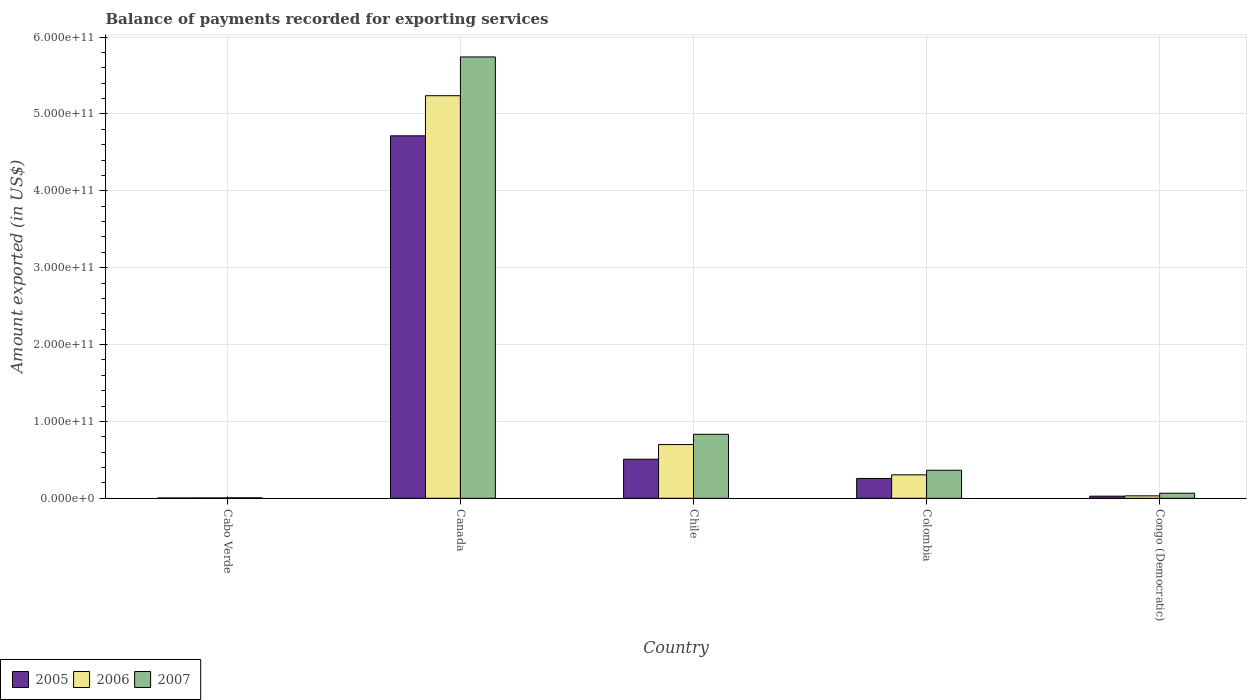How many different coloured bars are there?
Your response must be concise. 3. How many groups of bars are there?
Offer a very short reply. 5. How many bars are there on the 4th tick from the left?
Your answer should be compact. 3. How many bars are there on the 1st tick from the right?
Your answer should be very brief. 3. What is the label of the 5th group of bars from the left?
Offer a very short reply. Congo (Democratic). What is the amount exported in 2006 in Canada?
Your answer should be very brief. 5.24e+11. Across all countries, what is the maximum amount exported in 2007?
Offer a very short reply. 5.74e+11. Across all countries, what is the minimum amount exported in 2005?
Give a very brief answer. 3.73e+08. In which country was the amount exported in 2005 minimum?
Offer a terse response. Cabo Verde. What is the total amount exported in 2007 in the graph?
Your answer should be very brief. 7.01e+11. What is the difference between the amount exported in 2005 in Chile and that in Colombia?
Provide a succinct answer. 2.51e+1. What is the difference between the amount exported in 2005 in Congo (Democratic) and the amount exported in 2007 in Colombia?
Keep it short and to the point. -3.37e+1. What is the average amount exported in 2006 per country?
Your answer should be very brief. 1.26e+11. What is the difference between the amount exported of/in 2005 and amount exported of/in 2007 in Canada?
Your answer should be compact. -1.03e+11. In how many countries, is the amount exported in 2005 greater than 540000000000 US$?
Offer a very short reply. 0. What is the ratio of the amount exported in 2006 in Cabo Verde to that in Congo (Democratic)?
Keep it short and to the point. 0.16. Is the amount exported in 2007 in Cabo Verde less than that in Canada?
Ensure brevity in your answer.  Yes. Is the difference between the amount exported in 2005 in Canada and Colombia greater than the difference between the amount exported in 2007 in Canada and Colombia?
Make the answer very short. No. What is the difference between the highest and the second highest amount exported in 2006?
Offer a terse response. 3.94e+1. What is the difference between the highest and the lowest amount exported in 2007?
Make the answer very short. 5.74e+11. In how many countries, is the amount exported in 2007 greater than the average amount exported in 2007 taken over all countries?
Your answer should be very brief. 1. What does the 2nd bar from the left in Cabo Verde represents?
Provide a short and direct response. 2006. What does the 3rd bar from the right in Chile represents?
Keep it short and to the point. 2005. How many bars are there?
Keep it short and to the point. 15. Are all the bars in the graph horizontal?
Keep it short and to the point. No. What is the difference between two consecutive major ticks on the Y-axis?
Provide a short and direct response. 1.00e+11. Are the values on the major ticks of Y-axis written in scientific E-notation?
Provide a succinct answer. Yes. Does the graph contain grids?
Your response must be concise. Yes. Where does the legend appear in the graph?
Keep it short and to the point. Bottom left. How many legend labels are there?
Your answer should be compact. 3. How are the legend labels stacked?
Provide a succinct answer. Horizontal. What is the title of the graph?
Keep it short and to the point. Balance of payments recorded for exporting services. What is the label or title of the Y-axis?
Ensure brevity in your answer.  Amount exported (in US$). What is the Amount exported (in US$) of 2005 in Cabo Verde?
Provide a succinct answer. 3.73e+08. What is the Amount exported (in US$) in 2006 in Cabo Verde?
Your answer should be compact. 4.91e+08. What is the Amount exported (in US$) of 2007 in Cabo Verde?
Provide a succinct answer. 5.93e+08. What is the Amount exported (in US$) of 2005 in Canada?
Your response must be concise. 4.72e+11. What is the Amount exported (in US$) in 2006 in Canada?
Offer a terse response. 5.24e+11. What is the Amount exported (in US$) of 2007 in Canada?
Give a very brief answer. 5.74e+11. What is the Amount exported (in US$) of 2005 in Chile?
Offer a terse response. 5.09e+1. What is the Amount exported (in US$) of 2006 in Chile?
Make the answer very short. 6.99e+1. What is the Amount exported (in US$) of 2007 in Chile?
Provide a succinct answer. 8.33e+1. What is the Amount exported (in US$) of 2005 in Colombia?
Offer a very short reply. 2.58e+1. What is the Amount exported (in US$) in 2006 in Colombia?
Offer a terse response. 3.05e+1. What is the Amount exported (in US$) of 2007 in Colombia?
Your answer should be very brief. 3.65e+1. What is the Amount exported (in US$) in 2005 in Congo (Democratic)?
Your answer should be compact. 2.76e+09. What is the Amount exported (in US$) of 2006 in Congo (Democratic)?
Your response must be concise. 3.16e+09. What is the Amount exported (in US$) in 2007 in Congo (Democratic)?
Offer a very short reply. 6.57e+09. Across all countries, what is the maximum Amount exported (in US$) in 2005?
Provide a succinct answer. 4.72e+11. Across all countries, what is the maximum Amount exported (in US$) of 2006?
Give a very brief answer. 5.24e+11. Across all countries, what is the maximum Amount exported (in US$) in 2007?
Give a very brief answer. 5.74e+11. Across all countries, what is the minimum Amount exported (in US$) in 2005?
Your response must be concise. 3.73e+08. Across all countries, what is the minimum Amount exported (in US$) in 2006?
Keep it short and to the point. 4.91e+08. Across all countries, what is the minimum Amount exported (in US$) of 2007?
Provide a succinct answer. 5.93e+08. What is the total Amount exported (in US$) of 2005 in the graph?
Your answer should be compact. 5.51e+11. What is the total Amount exported (in US$) in 2006 in the graph?
Ensure brevity in your answer.  6.28e+11. What is the total Amount exported (in US$) in 2007 in the graph?
Offer a terse response. 7.01e+11. What is the difference between the Amount exported (in US$) in 2005 in Cabo Verde and that in Canada?
Give a very brief answer. -4.71e+11. What is the difference between the Amount exported (in US$) of 2006 in Cabo Verde and that in Canada?
Your response must be concise. -5.23e+11. What is the difference between the Amount exported (in US$) in 2007 in Cabo Verde and that in Canada?
Offer a very short reply. -5.74e+11. What is the difference between the Amount exported (in US$) of 2005 in Cabo Verde and that in Chile?
Make the answer very short. -5.05e+1. What is the difference between the Amount exported (in US$) of 2006 in Cabo Verde and that in Chile?
Your answer should be very brief. -6.94e+1. What is the difference between the Amount exported (in US$) in 2007 in Cabo Verde and that in Chile?
Ensure brevity in your answer.  -8.27e+1. What is the difference between the Amount exported (in US$) in 2005 in Cabo Verde and that in Colombia?
Keep it short and to the point. -2.54e+1. What is the difference between the Amount exported (in US$) of 2006 in Cabo Verde and that in Colombia?
Your answer should be compact. -3.00e+1. What is the difference between the Amount exported (in US$) of 2007 in Cabo Verde and that in Colombia?
Your answer should be very brief. -3.59e+1. What is the difference between the Amount exported (in US$) in 2005 in Cabo Verde and that in Congo (Democratic)?
Offer a very short reply. -2.38e+09. What is the difference between the Amount exported (in US$) in 2006 in Cabo Verde and that in Congo (Democratic)?
Your response must be concise. -2.66e+09. What is the difference between the Amount exported (in US$) in 2007 in Cabo Verde and that in Congo (Democratic)?
Give a very brief answer. -5.97e+09. What is the difference between the Amount exported (in US$) in 2005 in Canada and that in Chile?
Offer a very short reply. 4.21e+11. What is the difference between the Amount exported (in US$) in 2006 in Canada and that in Chile?
Provide a succinct answer. 4.54e+11. What is the difference between the Amount exported (in US$) of 2007 in Canada and that in Chile?
Offer a very short reply. 4.91e+11. What is the difference between the Amount exported (in US$) of 2005 in Canada and that in Colombia?
Make the answer very short. 4.46e+11. What is the difference between the Amount exported (in US$) in 2006 in Canada and that in Colombia?
Provide a succinct answer. 4.93e+11. What is the difference between the Amount exported (in US$) in 2007 in Canada and that in Colombia?
Your response must be concise. 5.38e+11. What is the difference between the Amount exported (in US$) of 2005 in Canada and that in Congo (Democratic)?
Give a very brief answer. 4.69e+11. What is the difference between the Amount exported (in US$) in 2006 in Canada and that in Congo (Democratic)?
Offer a very short reply. 5.21e+11. What is the difference between the Amount exported (in US$) of 2007 in Canada and that in Congo (Democratic)?
Make the answer very short. 5.68e+11. What is the difference between the Amount exported (in US$) of 2005 in Chile and that in Colombia?
Your response must be concise. 2.51e+1. What is the difference between the Amount exported (in US$) of 2006 in Chile and that in Colombia?
Ensure brevity in your answer.  3.94e+1. What is the difference between the Amount exported (in US$) of 2007 in Chile and that in Colombia?
Give a very brief answer. 4.68e+1. What is the difference between the Amount exported (in US$) of 2005 in Chile and that in Congo (Democratic)?
Your answer should be very brief. 4.81e+1. What is the difference between the Amount exported (in US$) in 2006 in Chile and that in Congo (Democratic)?
Keep it short and to the point. 6.67e+1. What is the difference between the Amount exported (in US$) in 2007 in Chile and that in Congo (Democratic)?
Your answer should be compact. 7.67e+1. What is the difference between the Amount exported (in US$) in 2005 in Colombia and that in Congo (Democratic)?
Your answer should be very brief. 2.30e+1. What is the difference between the Amount exported (in US$) in 2006 in Colombia and that in Congo (Democratic)?
Offer a very short reply. 2.73e+1. What is the difference between the Amount exported (in US$) in 2007 in Colombia and that in Congo (Democratic)?
Provide a succinct answer. 2.99e+1. What is the difference between the Amount exported (in US$) of 2005 in Cabo Verde and the Amount exported (in US$) of 2006 in Canada?
Provide a short and direct response. -5.23e+11. What is the difference between the Amount exported (in US$) of 2005 in Cabo Verde and the Amount exported (in US$) of 2007 in Canada?
Give a very brief answer. -5.74e+11. What is the difference between the Amount exported (in US$) in 2006 in Cabo Verde and the Amount exported (in US$) in 2007 in Canada?
Give a very brief answer. -5.74e+11. What is the difference between the Amount exported (in US$) of 2005 in Cabo Verde and the Amount exported (in US$) of 2006 in Chile?
Provide a short and direct response. -6.95e+1. What is the difference between the Amount exported (in US$) of 2005 in Cabo Verde and the Amount exported (in US$) of 2007 in Chile?
Offer a terse response. -8.29e+1. What is the difference between the Amount exported (in US$) in 2006 in Cabo Verde and the Amount exported (in US$) in 2007 in Chile?
Give a very brief answer. -8.28e+1. What is the difference between the Amount exported (in US$) in 2005 in Cabo Verde and the Amount exported (in US$) in 2006 in Colombia?
Keep it short and to the point. -3.01e+1. What is the difference between the Amount exported (in US$) of 2005 in Cabo Verde and the Amount exported (in US$) of 2007 in Colombia?
Your response must be concise. -3.61e+1. What is the difference between the Amount exported (in US$) in 2006 in Cabo Verde and the Amount exported (in US$) in 2007 in Colombia?
Provide a succinct answer. -3.60e+1. What is the difference between the Amount exported (in US$) of 2005 in Cabo Verde and the Amount exported (in US$) of 2006 in Congo (Democratic)?
Keep it short and to the point. -2.78e+09. What is the difference between the Amount exported (in US$) of 2005 in Cabo Verde and the Amount exported (in US$) of 2007 in Congo (Democratic)?
Offer a terse response. -6.19e+09. What is the difference between the Amount exported (in US$) in 2006 in Cabo Verde and the Amount exported (in US$) in 2007 in Congo (Democratic)?
Ensure brevity in your answer.  -6.07e+09. What is the difference between the Amount exported (in US$) in 2005 in Canada and the Amount exported (in US$) in 2006 in Chile?
Your response must be concise. 4.02e+11. What is the difference between the Amount exported (in US$) of 2005 in Canada and the Amount exported (in US$) of 2007 in Chile?
Your response must be concise. 3.88e+11. What is the difference between the Amount exported (in US$) in 2006 in Canada and the Amount exported (in US$) in 2007 in Chile?
Ensure brevity in your answer.  4.40e+11. What is the difference between the Amount exported (in US$) in 2005 in Canada and the Amount exported (in US$) in 2006 in Colombia?
Offer a very short reply. 4.41e+11. What is the difference between the Amount exported (in US$) in 2005 in Canada and the Amount exported (in US$) in 2007 in Colombia?
Offer a terse response. 4.35e+11. What is the difference between the Amount exported (in US$) in 2006 in Canada and the Amount exported (in US$) in 2007 in Colombia?
Give a very brief answer. 4.87e+11. What is the difference between the Amount exported (in US$) in 2005 in Canada and the Amount exported (in US$) in 2006 in Congo (Democratic)?
Provide a short and direct response. 4.68e+11. What is the difference between the Amount exported (in US$) in 2005 in Canada and the Amount exported (in US$) in 2007 in Congo (Democratic)?
Give a very brief answer. 4.65e+11. What is the difference between the Amount exported (in US$) in 2006 in Canada and the Amount exported (in US$) in 2007 in Congo (Democratic)?
Provide a short and direct response. 5.17e+11. What is the difference between the Amount exported (in US$) of 2005 in Chile and the Amount exported (in US$) of 2006 in Colombia?
Make the answer very short. 2.04e+1. What is the difference between the Amount exported (in US$) in 2005 in Chile and the Amount exported (in US$) in 2007 in Colombia?
Your answer should be compact. 1.44e+1. What is the difference between the Amount exported (in US$) of 2006 in Chile and the Amount exported (in US$) of 2007 in Colombia?
Ensure brevity in your answer.  3.34e+1. What is the difference between the Amount exported (in US$) of 2005 in Chile and the Amount exported (in US$) of 2006 in Congo (Democratic)?
Your answer should be compact. 4.77e+1. What is the difference between the Amount exported (in US$) in 2005 in Chile and the Amount exported (in US$) in 2007 in Congo (Democratic)?
Keep it short and to the point. 4.43e+1. What is the difference between the Amount exported (in US$) in 2006 in Chile and the Amount exported (in US$) in 2007 in Congo (Democratic)?
Offer a very short reply. 6.33e+1. What is the difference between the Amount exported (in US$) in 2005 in Colombia and the Amount exported (in US$) in 2006 in Congo (Democratic)?
Ensure brevity in your answer.  2.26e+1. What is the difference between the Amount exported (in US$) of 2005 in Colombia and the Amount exported (in US$) of 2007 in Congo (Democratic)?
Keep it short and to the point. 1.92e+1. What is the difference between the Amount exported (in US$) in 2006 in Colombia and the Amount exported (in US$) in 2007 in Congo (Democratic)?
Provide a short and direct response. 2.39e+1. What is the average Amount exported (in US$) of 2005 per country?
Your response must be concise. 1.10e+11. What is the average Amount exported (in US$) in 2006 per country?
Your answer should be very brief. 1.26e+11. What is the average Amount exported (in US$) of 2007 per country?
Provide a short and direct response. 1.40e+11. What is the difference between the Amount exported (in US$) of 2005 and Amount exported (in US$) of 2006 in Cabo Verde?
Provide a short and direct response. -1.18e+08. What is the difference between the Amount exported (in US$) of 2005 and Amount exported (in US$) of 2007 in Cabo Verde?
Offer a terse response. -2.20e+08. What is the difference between the Amount exported (in US$) of 2006 and Amount exported (in US$) of 2007 in Cabo Verde?
Ensure brevity in your answer.  -1.01e+08. What is the difference between the Amount exported (in US$) of 2005 and Amount exported (in US$) of 2006 in Canada?
Give a very brief answer. -5.22e+1. What is the difference between the Amount exported (in US$) of 2005 and Amount exported (in US$) of 2007 in Canada?
Make the answer very short. -1.03e+11. What is the difference between the Amount exported (in US$) in 2006 and Amount exported (in US$) in 2007 in Canada?
Your answer should be very brief. -5.04e+1. What is the difference between the Amount exported (in US$) of 2005 and Amount exported (in US$) of 2006 in Chile?
Give a very brief answer. -1.90e+1. What is the difference between the Amount exported (in US$) of 2005 and Amount exported (in US$) of 2007 in Chile?
Offer a terse response. -3.24e+1. What is the difference between the Amount exported (in US$) in 2006 and Amount exported (in US$) in 2007 in Chile?
Keep it short and to the point. -1.34e+1. What is the difference between the Amount exported (in US$) in 2005 and Amount exported (in US$) in 2006 in Colombia?
Your answer should be compact. -4.70e+09. What is the difference between the Amount exported (in US$) in 2005 and Amount exported (in US$) in 2007 in Colombia?
Make the answer very short. -1.07e+1. What is the difference between the Amount exported (in US$) in 2006 and Amount exported (in US$) in 2007 in Colombia?
Offer a terse response. -5.97e+09. What is the difference between the Amount exported (in US$) of 2005 and Amount exported (in US$) of 2006 in Congo (Democratic)?
Your answer should be compact. -4.00e+08. What is the difference between the Amount exported (in US$) of 2005 and Amount exported (in US$) of 2007 in Congo (Democratic)?
Your answer should be very brief. -3.81e+09. What is the difference between the Amount exported (in US$) in 2006 and Amount exported (in US$) in 2007 in Congo (Democratic)?
Provide a short and direct response. -3.41e+09. What is the ratio of the Amount exported (in US$) in 2005 in Cabo Verde to that in Canada?
Provide a succinct answer. 0. What is the ratio of the Amount exported (in US$) of 2006 in Cabo Verde to that in Canada?
Keep it short and to the point. 0. What is the ratio of the Amount exported (in US$) of 2007 in Cabo Verde to that in Canada?
Offer a very short reply. 0. What is the ratio of the Amount exported (in US$) of 2005 in Cabo Verde to that in Chile?
Make the answer very short. 0.01. What is the ratio of the Amount exported (in US$) of 2006 in Cabo Verde to that in Chile?
Your response must be concise. 0.01. What is the ratio of the Amount exported (in US$) of 2007 in Cabo Verde to that in Chile?
Offer a very short reply. 0.01. What is the ratio of the Amount exported (in US$) in 2005 in Cabo Verde to that in Colombia?
Keep it short and to the point. 0.01. What is the ratio of the Amount exported (in US$) of 2006 in Cabo Verde to that in Colombia?
Keep it short and to the point. 0.02. What is the ratio of the Amount exported (in US$) in 2007 in Cabo Verde to that in Colombia?
Give a very brief answer. 0.02. What is the ratio of the Amount exported (in US$) of 2005 in Cabo Verde to that in Congo (Democratic)?
Your response must be concise. 0.14. What is the ratio of the Amount exported (in US$) in 2006 in Cabo Verde to that in Congo (Democratic)?
Offer a very short reply. 0.16. What is the ratio of the Amount exported (in US$) in 2007 in Cabo Verde to that in Congo (Democratic)?
Your response must be concise. 0.09. What is the ratio of the Amount exported (in US$) in 2005 in Canada to that in Chile?
Your response must be concise. 9.27. What is the ratio of the Amount exported (in US$) in 2006 in Canada to that in Chile?
Keep it short and to the point. 7.49. What is the ratio of the Amount exported (in US$) in 2007 in Canada to that in Chile?
Provide a short and direct response. 6.9. What is the ratio of the Amount exported (in US$) of 2005 in Canada to that in Colombia?
Provide a short and direct response. 18.29. What is the ratio of the Amount exported (in US$) of 2006 in Canada to that in Colombia?
Give a very brief answer. 17.18. What is the ratio of the Amount exported (in US$) of 2007 in Canada to that in Colombia?
Ensure brevity in your answer.  15.75. What is the ratio of the Amount exported (in US$) of 2005 in Canada to that in Congo (Democratic)?
Keep it short and to the point. 171.13. What is the ratio of the Amount exported (in US$) of 2006 in Canada to that in Congo (Democratic)?
Offer a very short reply. 165.99. What is the ratio of the Amount exported (in US$) of 2007 in Canada to that in Congo (Democratic)?
Give a very brief answer. 87.44. What is the ratio of the Amount exported (in US$) in 2005 in Chile to that in Colombia?
Ensure brevity in your answer.  1.97. What is the ratio of the Amount exported (in US$) in 2006 in Chile to that in Colombia?
Provide a succinct answer. 2.29. What is the ratio of the Amount exported (in US$) in 2007 in Chile to that in Colombia?
Give a very brief answer. 2.28. What is the ratio of the Amount exported (in US$) in 2005 in Chile to that in Congo (Democratic)?
Keep it short and to the point. 18.46. What is the ratio of the Amount exported (in US$) in 2006 in Chile to that in Congo (Democratic)?
Ensure brevity in your answer.  22.15. What is the ratio of the Amount exported (in US$) of 2007 in Chile to that in Congo (Democratic)?
Provide a short and direct response. 12.68. What is the ratio of the Amount exported (in US$) of 2005 in Colombia to that in Congo (Democratic)?
Offer a terse response. 9.36. What is the ratio of the Amount exported (in US$) in 2006 in Colombia to that in Congo (Democratic)?
Your response must be concise. 9.66. What is the ratio of the Amount exported (in US$) in 2007 in Colombia to that in Congo (Democratic)?
Your answer should be very brief. 5.55. What is the difference between the highest and the second highest Amount exported (in US$) in 2005?
Your response must be concise. 4.21e+11. What is the difference between the highest and the second highest Amount exported (in US$) in 2006?
Ensure brevity in your answer.  4.54e+11. What is the difference between the highest and the second highest Amount exported (in US$) of 2007?
Your answer should be very brief. 4.91e+11. What is the difference between the highest and the lowest Amount exported (in US$) of 2005?
Provide a succinct answer. 4.71e+11. What is the difference between the highest and the lowest Amount exported (in US$) in 2006?
Keep it short and to the point. 5.23e+11. What is the difference between the highest and the lowest Amount exported (in US$) of 2007?
Make the answer very short. 5.74e+11. 